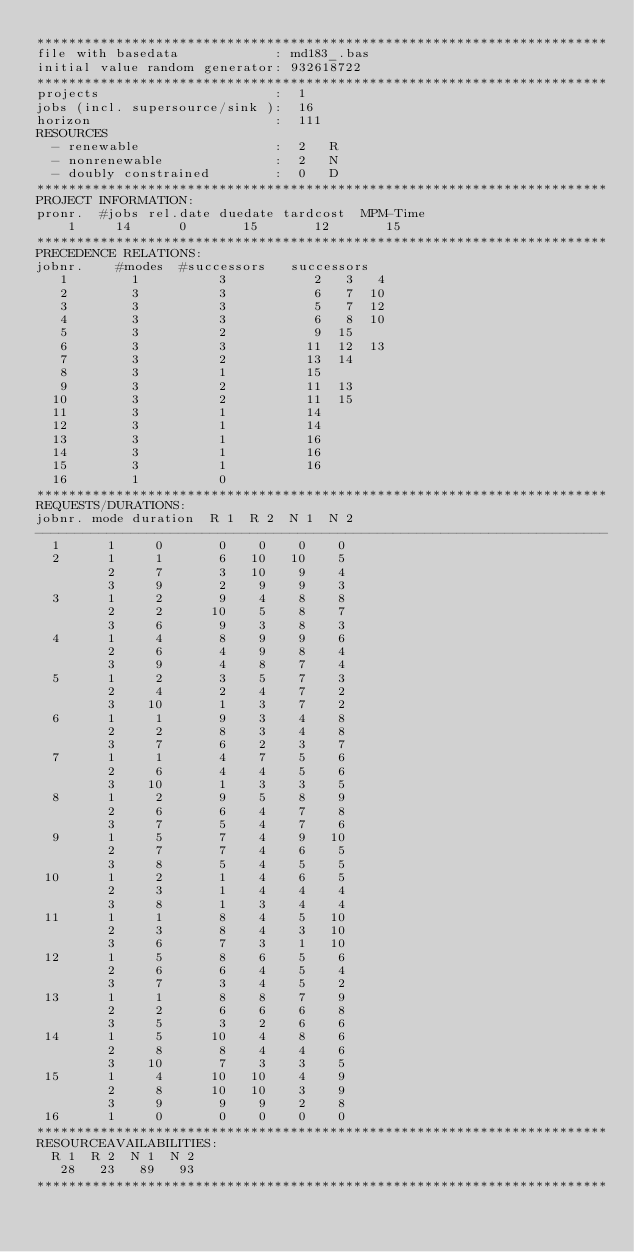<code> <loc_0><loc_0><loc_500><loc_500><_ObjectiveC_>************************************************************************
file with basedata            : md183_.bas
initial value random generator: 932618722
************************************************************************
projects                      :  1
jobs (incl. supersource/sink ):  16
horizon                       :  111
RESOURCES
  - renewable                 :  2   R
  - nonrenewable              :  2   N
  - doubly constrained        :  0   D
************************************************************************
PROJECT INFORMATION:
pronr.  #jobs rel.date duedate tardcost  MPM-Time
    1     14      0       15       12       15
************************************************************************
PRECEDENCE RELATIONS:
jobnr.    #modes  #successors   successors
   1        1          3           2   3   4
   2        3          3           6   7  10
   3        3          3           5   7  12
   4        3          3           6   8  10
   5        3          2           9  15
   6        3          3          11  12  13
   7        3          2          13  14
   8        3          1          15
   9        3          2          11  13
  10        3          2          11  15
  11        3          1          14
  12        3          1          14
  13        3          1          16
  14        3          1          16
  15        3          1          16
  16        1          0        
************************************************************************
REQUESTS/DURATIONS:
jobnr. mode duration  R 1  R 2  N 1  N 2
------------------------------------------------------------------------
  1      1     0       0    0    0    0
  2      1     1       6   10   10    5
         2     7       3   10    9    4
         3     9       2    9    9    3
  3      1     2       9    4    8    8
         2     2      10    5    8    7
         3     6       9    3    8    3
  4      1     4       8    9    9    6
         2     6       4    9    8    4
         3     9       4    8    7    4
  5      1     2       3    5    7    3
         2     4       2    4    7    2
         3    10       1    3    7    2
  6      1     1       9    3    4    8
         2     2       8    3    4    8
         3     7       6    2    3    7
  7      1     1       4    7    5    6
         2     6       4    4    5    6
         3    10       1    3    3    5
  8      1     2       9    5    8    9
         2     6       6    4    7    8
         3     7       5    4    7    6
  9      1     5       7    4    9   10
         2     7       7    4    6    5
         3     8       5    4    5    5
 10      1     2       1    4    6    5
         2     3       1    4    4    4
         3     8       1    3    4    4
 11      1     1       8    4    5   10
         2     3       8    4    3   10
         3     6       7    3    1   10
 12      1     5       8    6    5    6
         2     6       6    4    5    4
         3     7       3    4    5    2
 13      1     1       8    8    7    9
         2     2       6    6    6    8
         3     5       3    2    6    6
 14      1     5      10    4    8    6
         2     8       8    4    4    6
         3    10       7    3    3    5
 15      1     4      10   10    4    9
         2     8      10   10    3    9
         3     9       9    9    2    8
 16      1     0       0    0    0    0
************************************************************************
RESOURCEAVAILABILITIES:
  R 1  R 2  N 1  N 2
   28   23   89   93
************************************************************************
</code> 